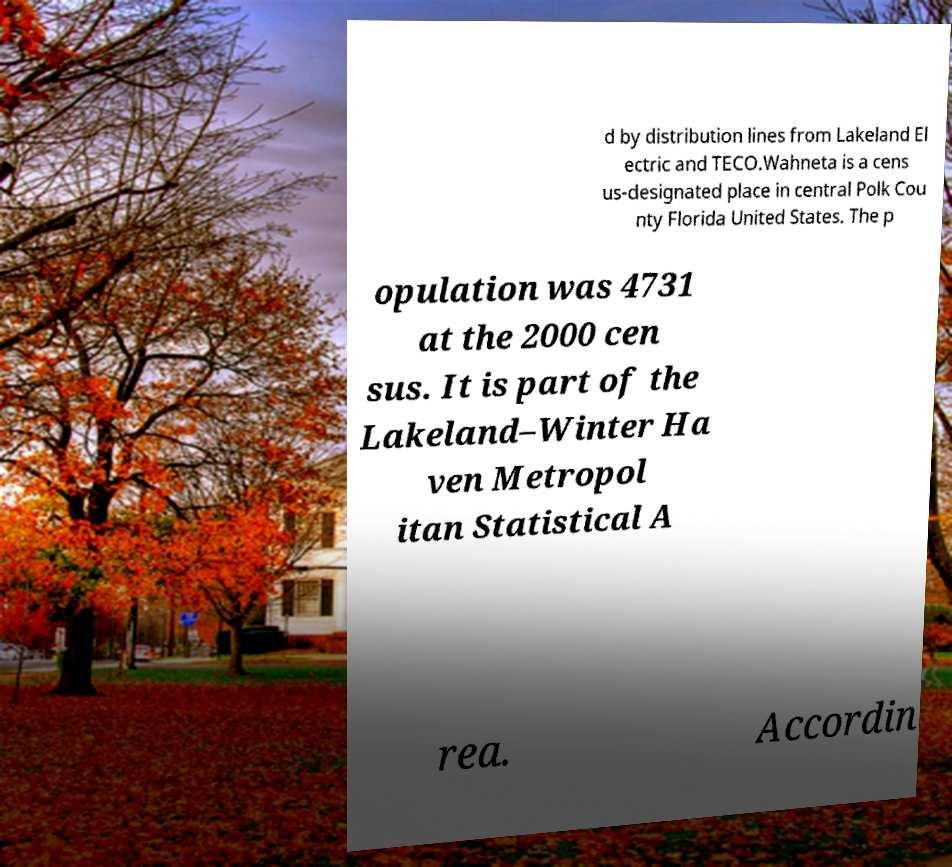Please read and relay the text visible in this image. What does it say? d by distribution lines from Lakeland El ectric and TECO.Wahneta is a cens us-designated place in central Polk Cou nty Florida United States. The p opulation was 4731 at the 2000 cen sus. It is part of the Lakeland–Winter Ha ven Metropol itan Statistical A rea. Accordin 